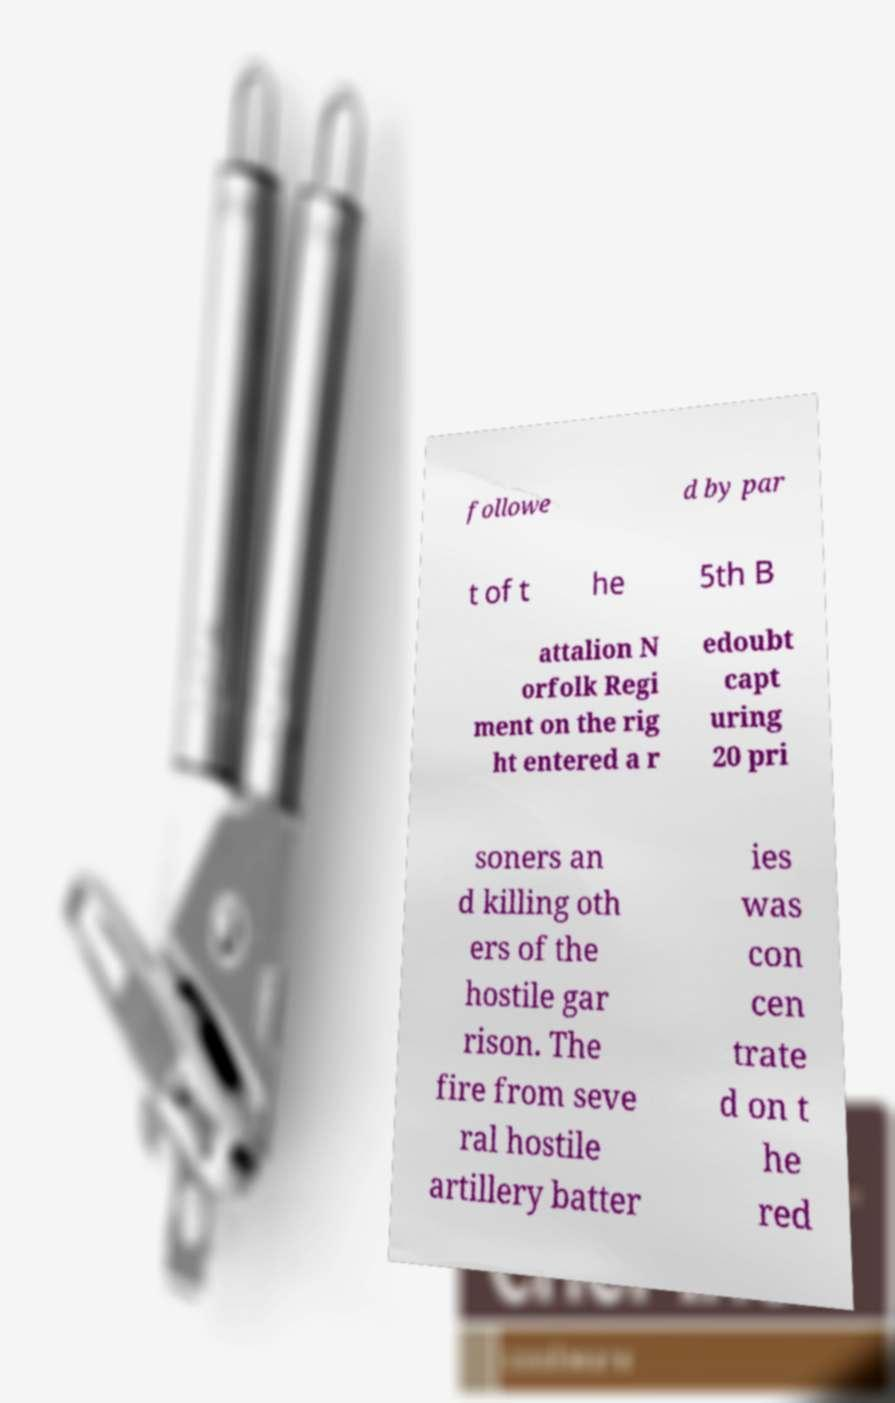Could you assist in decoding the text presented in this image and type it out clearly? followe d by par t of t he 5th B attalion N orfolk Regi ment on the rig ht entered a r edoubt capt uring 20 pri soners an d killing oth ers of the hostile gar rison. The fire from seve ral hostile artillery batter ies was con cen trate d on t he red 